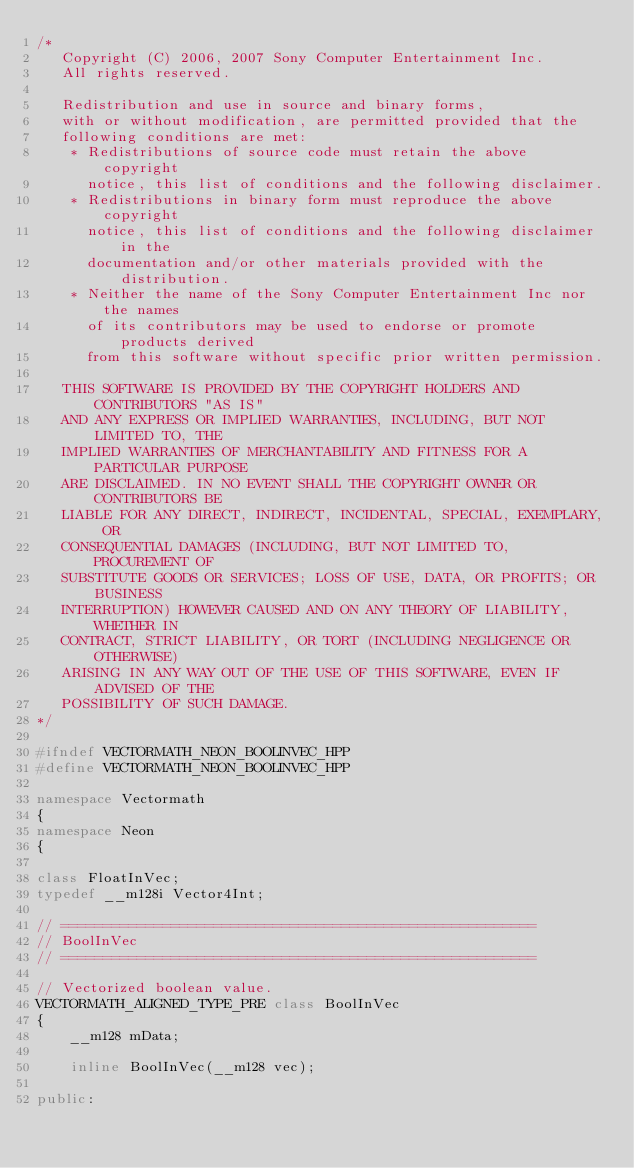<code> <loc_0><loc_0><loc_500><loc_500><_C++_>/*
   Copyright (C) 2006, 2007 Sony Computer Entertainment Inc.
   All rights reserved.

   Redistribution and use in source and binary forms,
   with or without modification, are permitted provided that the
   following conditions are met:
    * Redistributions of source code must retain the above copyright
      notice, this list of conditions and the following disclaimer.
    * Redistributions in binary form must reproduce the above copyright
      notice, this list of conditions and the following disclaimer in the
      documentation and/or other materials provided with the distribution.
    * Neither the name of the Sony Computer Entertainment Inc nor the names
      of its contributors may be used to endorse or promote products derived
      from this software without specific prior written permission.

   THIS SOFTWARE IS PROVIDED BY THE COPYRIGHT HOLDERS AND CONTRIBUTORS "AS IS"
   AND ANY EXPRESS OR IMPLIED WARRANTIES, INCLUDING, BUT NOT LIMITED TO, THE
   IMPLIED WARRANTIES OF MERCHANTABILITY AND FITNESS FOR A PARTICULAR PURPOSE
   ARE DISCLAIMED. IN NO EVENT SHALL THE COPYRIGHT OWNER OR CONTRIBUTORS BE
   LIABLE FOR ANY DIRECT, INDIRECT, INCIDENTAL, SPECIAL, EXEMPLARY, OR
   CONSEQUENTIAL DAMAGES (INCLUDING, BUT NOT LIMITED TO, PROCUREMENT OF
   SUBSTITUTE GOODS OR SERVICES; LOSS OF USE, DATA, OR PROFITS; OR BUSINESS
   INTERRUPTION) HOWEVER CAUSED AND ON ANY THEORY OF LIABILITY, WHETHER IN
   CONTRACT, STRICT LIABILITY, OR TORT (INCLUDING NEGLIGENCE OR OTHERWISE)
   ARISING IN ANY WAY OUT OF THE USE OF THIS SOFTWARE, EVEN IF ADVISED OF THE
   POSSIBILITY OF SUCH DAMAGE.
*/

#ifndef VECTORMATH_NEON_BOOLINVEC_HPP
#define VECTORMATH_NEON_BOOLINVEC_HPP

namespace Vectormath
{
namespace Neon
{

class FloatInVec;
typedef __m128i Vector4Int;

// ========================================================
// BoolInVec
// ========================================================

// Vectorized boolean value.
VECTORMATH_ALIGNED_TYPE_PRE class BoolInVec
{
    __m128 mData;

    inline BoolInVec(__m128 vec);

public:
</code> 